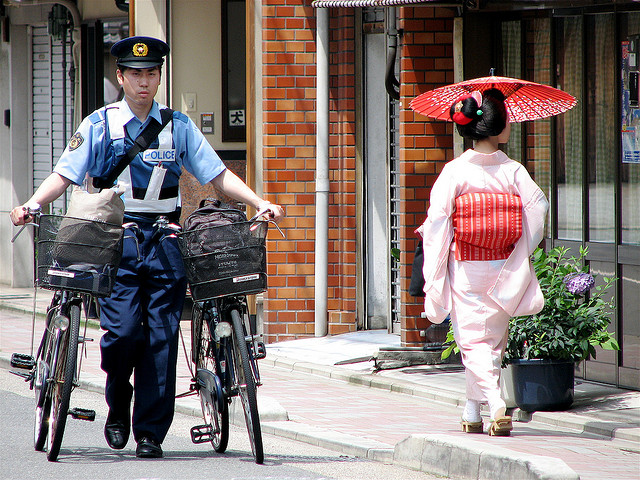Please transcribe the text information in this image. POLICE 